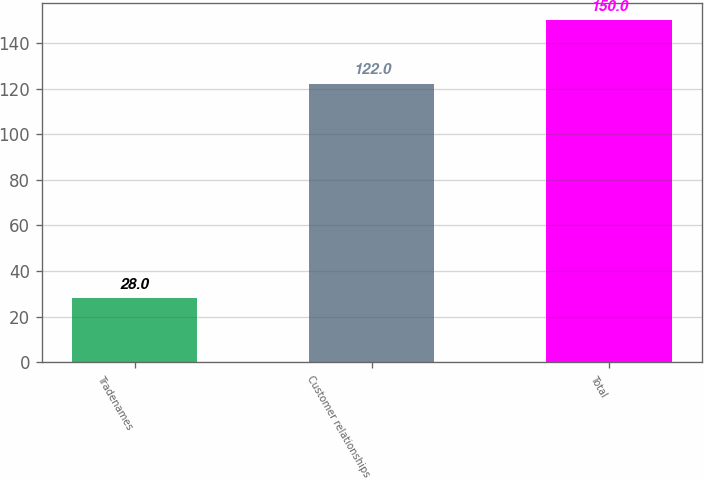Convert chart to OTSL. <chart><loc_0><loc_0><loc_500><loc_500><bar_chart><fcel>Tradenames<fcel>Customer relationships<fcel>Total<nl><fcel>28<fcel>122<fcel>150<nl></chart> 